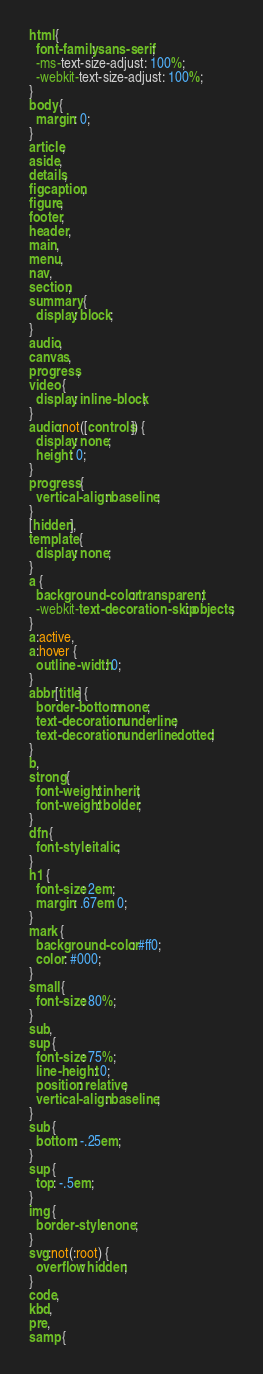Convert code to text. <code><loc_0><loc_0><loc_500><loc_500><_CSS_>html {
  font-family: sans-serif;
  -ms-text-size-adjust: 100%;
  -webkit-text-size-adjust: 100%;
}
body {
  margin: 0;
}
article,
aside,
details,
figcaption,
figure,
footer,
header,
main,
menu,
nav,
section,
summary {
  display: block;
}
audio,
canvas,
progress,
video {
  display: inline-block;
}
audio:not([controls]) {
  display: none;
  height: 0;
}
progress {
  vertical-align: baseline;
}
[hidden],
template {
  display: none;
}
a {
  background-color: transparent;
  -webkit-text-decoration-skip: objects;
}
a:active,
a:hover {
  outline-width: 0;
}
abbr[title] {
  border-bottom: none;
  text-decoration: underline;
  text-decoration: underline dotted;
}
b,
strong {
  font-weight: inherit;
  font-weight: bolder;
}
dfn {
  font-style: italic;
}
h1 {
  font-size: 2em;
  margin: .67em 0;
}
mark {
  background-color: #ff0;
  color: #000;
}
small {
  font-size: 80%;
}
sub,
sup {
  font-size: 75%;
  line-height: 0;
  position: relative;
  vertical-align: baseline;
}
sub {
  bottom: -.25em;
}
sup {
  top: -.5em;
}
img {
  border-style: none;
}
svg:not(:root) {
  overflow: hidden;
}
code,
kbd,
pre,
samp {</code> 